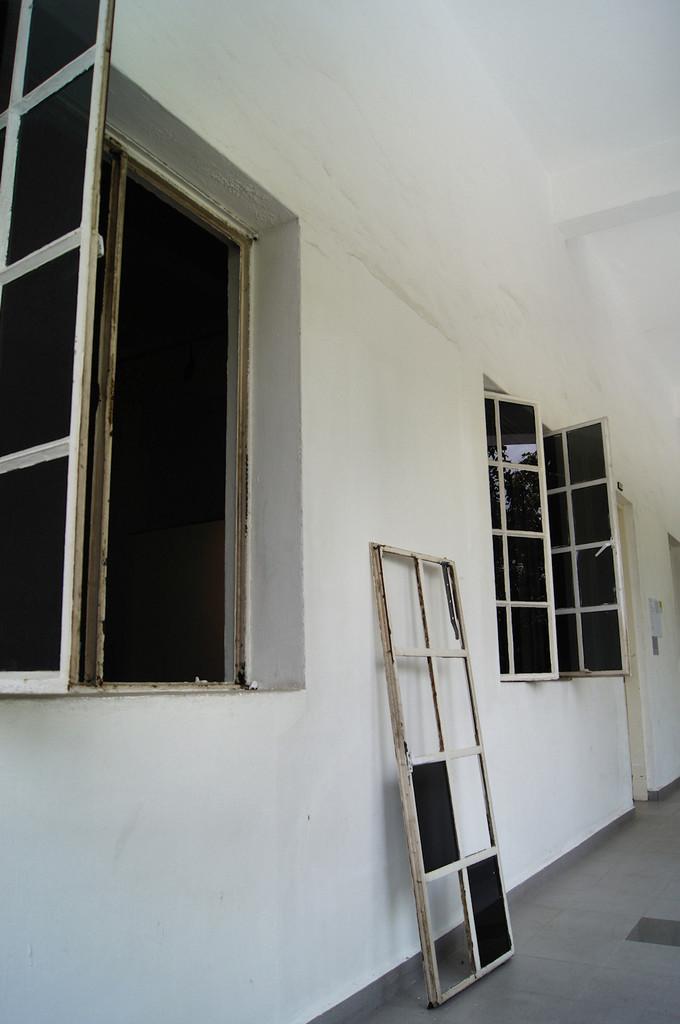Can you describe this image briefly? In this picture we see a wall with many windows and glass panes. 